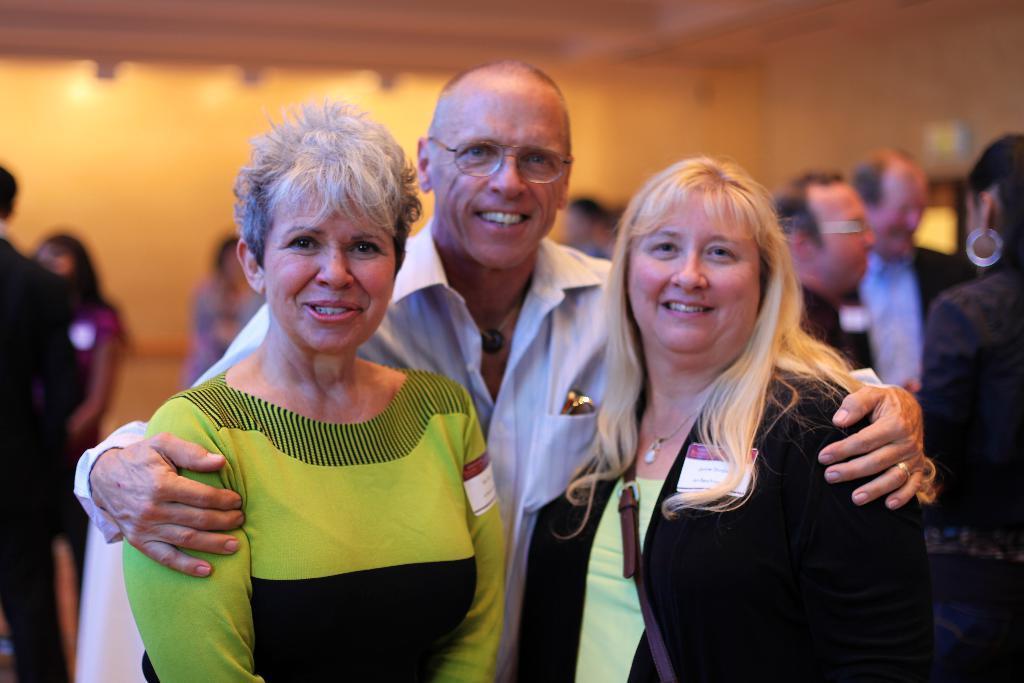In one or two sentences, can you explain what this image depicts? In this image in the foreground there are three persons standing and smiling, and one person is wearing a hand bag. And in the background there are a group of people and wall. 